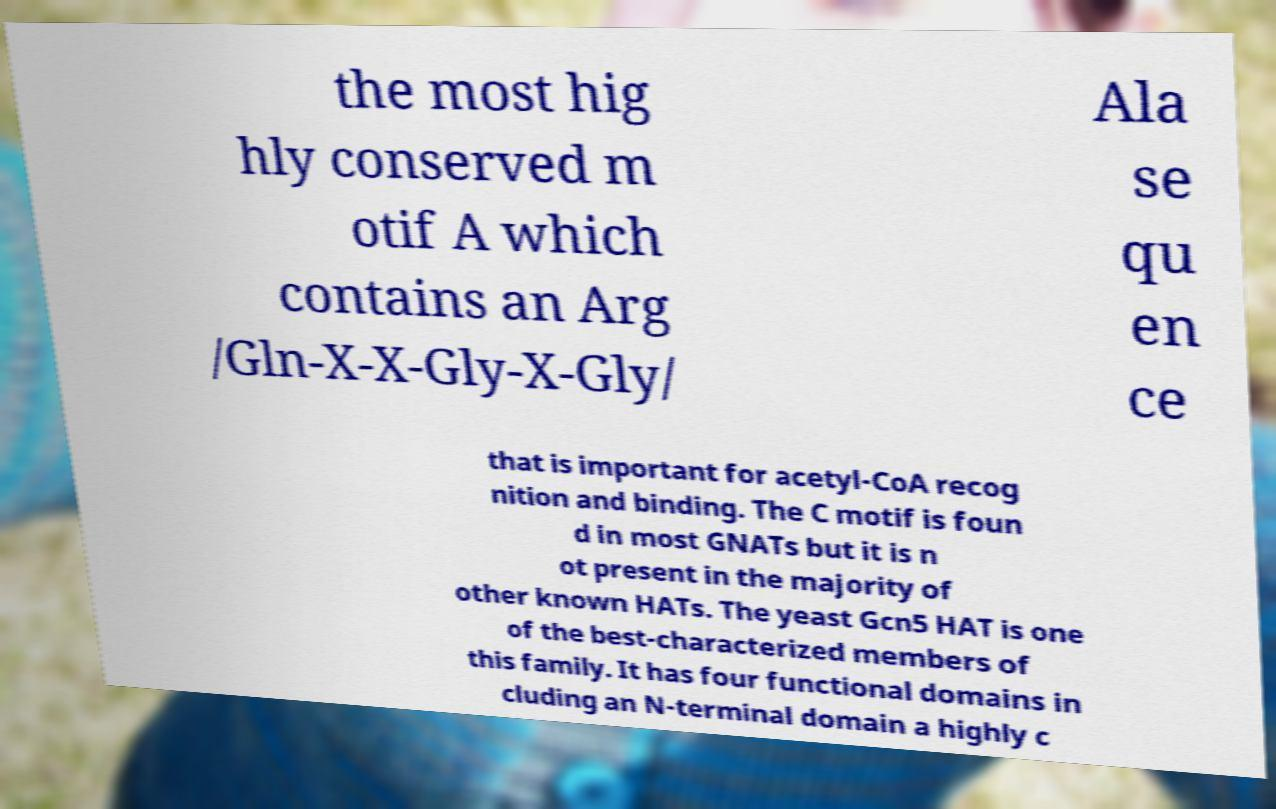I need the written content from this picture converted into text. Can you do that? the most hig hly conserved m otif A which contains an Arg /Gln-X-X-Gly-X-Gly/ Ala se qu en ce that is important for acetyl-CoA recog nition and binding. The C motif is foun d in most GNATs but it is n ot present in the majority of other known HATs. The yeast Gcn5 HAT is one of the best-characterized members of this family. It has four functional domains in cluding an N-terminal domain a highly c 